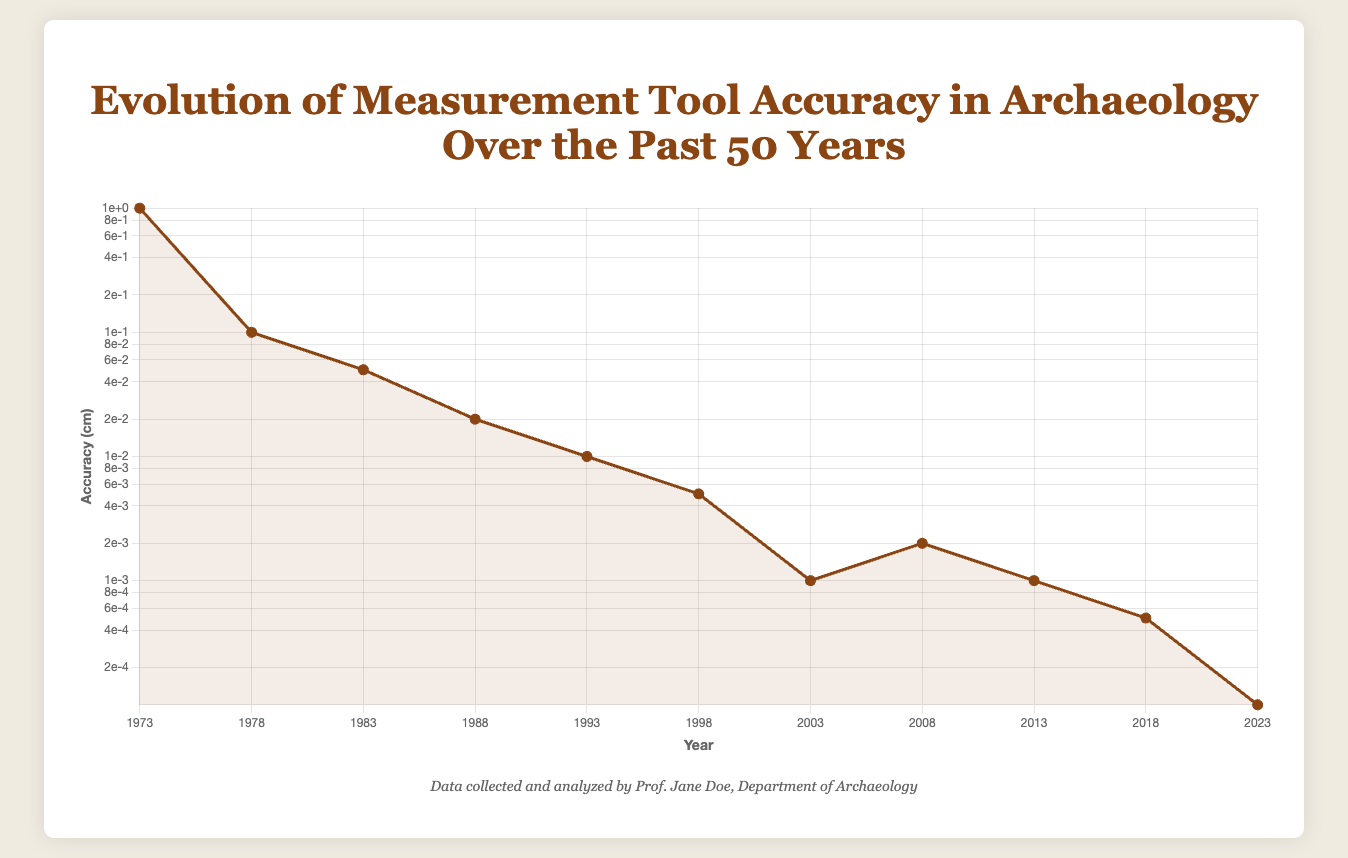How has the accuracy of measurement tools improved from 1973 to 2023? The accuracy has improved significantly over the years. In 1973, the tape measure had an accuracy of 1 cm, while in 2023, Quantum LiDAR has an accuracy of 0.0001 cm, showing a considerable improvement by several orders of magnitude.
Answer: From 1 cm to 0.0001 cm Which tool, marked in 2008, has better accuracy: Ground Penetrating Radar (GPR) or the Total Station from 1983? In 2008, GPR had an accuracy of 0.002 cm, while the Total Station in 1983 had an accuracy of 0.05 cm. Comparing the two, GPR has better accuracy.
Answer: GPR in 2008 Between which two consecutive years was the greatest improvement in measurement tool accuracy observed? The greatest improvement can be observed between 1978 and 1983. The accuracy improved from 0.1 cm with Caliper to 0.05 cm with Total Station, indicating a 0.05 cm improvement.
Answer: Between 1978 and 1983 What is the accuracy difference between the tools used in 1993 and 1998? The GPS in 1993 had an accuracy of 0.01 cm and the Laser Scanner in 1998 had an accuracy of 0.005 cm. The difference in accuracy is 0.01 cm - 0.005 cm = 0.005 cm.
Answer: 0.005 cm Which tool has the highest accuracy according to the plot? The Quantum LiDAR in 2023 has the highest accuracy, with an accuracy of 0.0001 cm.
Answer: Quantum LiDAR in 2023 Which decade showed the most significant improvement in measurement tool accuracy? The decade from 1993 to 2003 showed the most significant improvement. In 1993, GPS had an accuracy of 0.01 cm, and by 2003, Digital Caliper had an accuracy of 0.001 cm, indicating a tenfold improvement.
Answer: 1993 to 2003 What is the average accuracy of the tools introduced between 2003 and 2018? The tools are Digital Caliper (0.001 cm) in 2003, GPR (0.002 cm) in 2008, LiDAR (0.001 cm) in 2013, and 3D Photogrammetry (0.0005 cm) in 2018. Average accuracy = (0.001 + 0.002 + 0.001 + 0.0005) / 4 = 0.001125 cm.
Answer: 0.001125 cm After how many years did the accuracy of measurement tools improve from 0.1 cm to 0.0005 cm? The accuracy improved from 0.1 cm in 1978 (Caliper) to 0.0005 cm in 2018 (3D Photogrammetry). The number of years between 1978 and 2018 is 2018 - 1978 = 40 years.
Answer: 40 years What was the accuracy of measurement tools in 1988 and how does it compare to the accuracy in 1998? In 1988, the accuracy was 0.02 cm (EDM). In 1998, the accuracy was 0.005 cm (Laser Scanner). The accuracy improved by 0.02 cm - 0.005 cm = 0.015 cm over this period.
Answer: Improved by 0.015 cm 